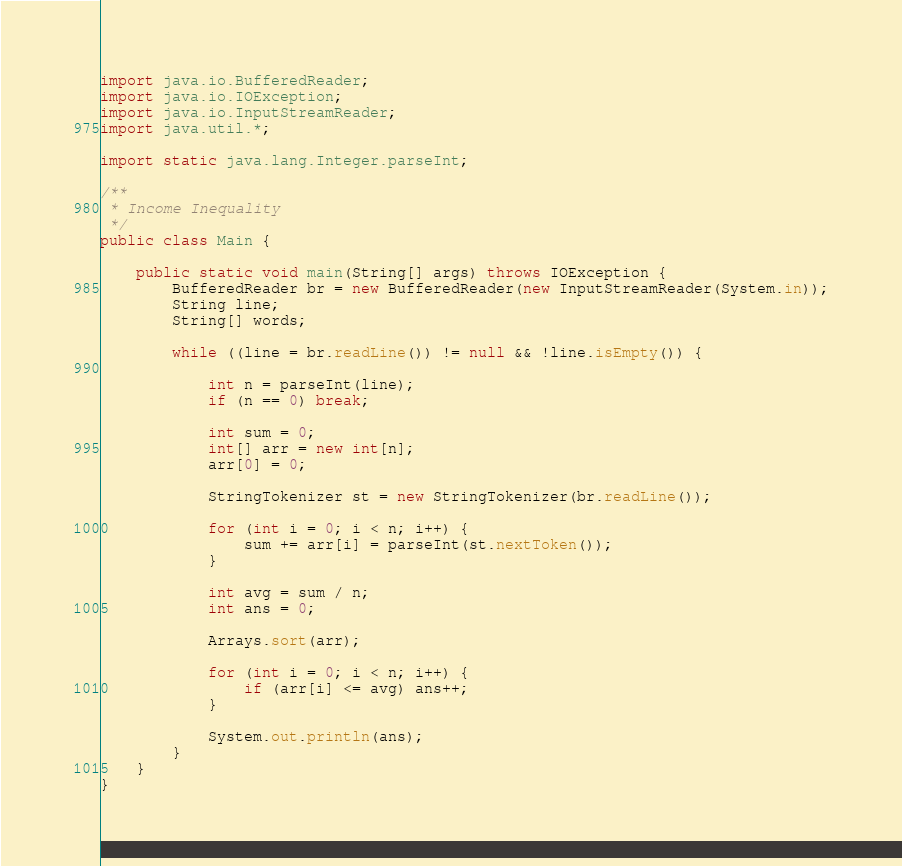Convert code to text. <code><loc_0><loc_0><loc_500><loc_500><_Java_>import java.io.BufferedReader;
import java.io.IOException;
import java.io.InputStreamReader;
import java.util.*;

import static java.lang.Integer.parseInt;

/**
 * Income Inequality
 */
public class Main {

	public static void main(String[] args) throws IOException {
		BufferedReader br = new BufferedReader(new InputStreamReader(System.in));
		String line;
		String[] words;

		while ((line = br.readLine()) != null && !line.isEmpty()) {

			int n = parseInt(line);
			if (n == 0) break;

			int sum = 0;
			int[] arr = new int[n];
			arr[0] = 0;

			StringTokenizer st = new StringTokenizer(br.readLine());

			for (int i = 0; i < n; i++) {
				sum += arr[i] = parseInt(st.nextToken());
			}

			int avg = sum / n;
			int ans = 0;

			Arrays.sort(arr);

			for (int i = 0; i < n; i++) {
				if (arr[i] <= avg) ans++;
			}

			System.out.println(ans);
		}
	}
}
</code> 